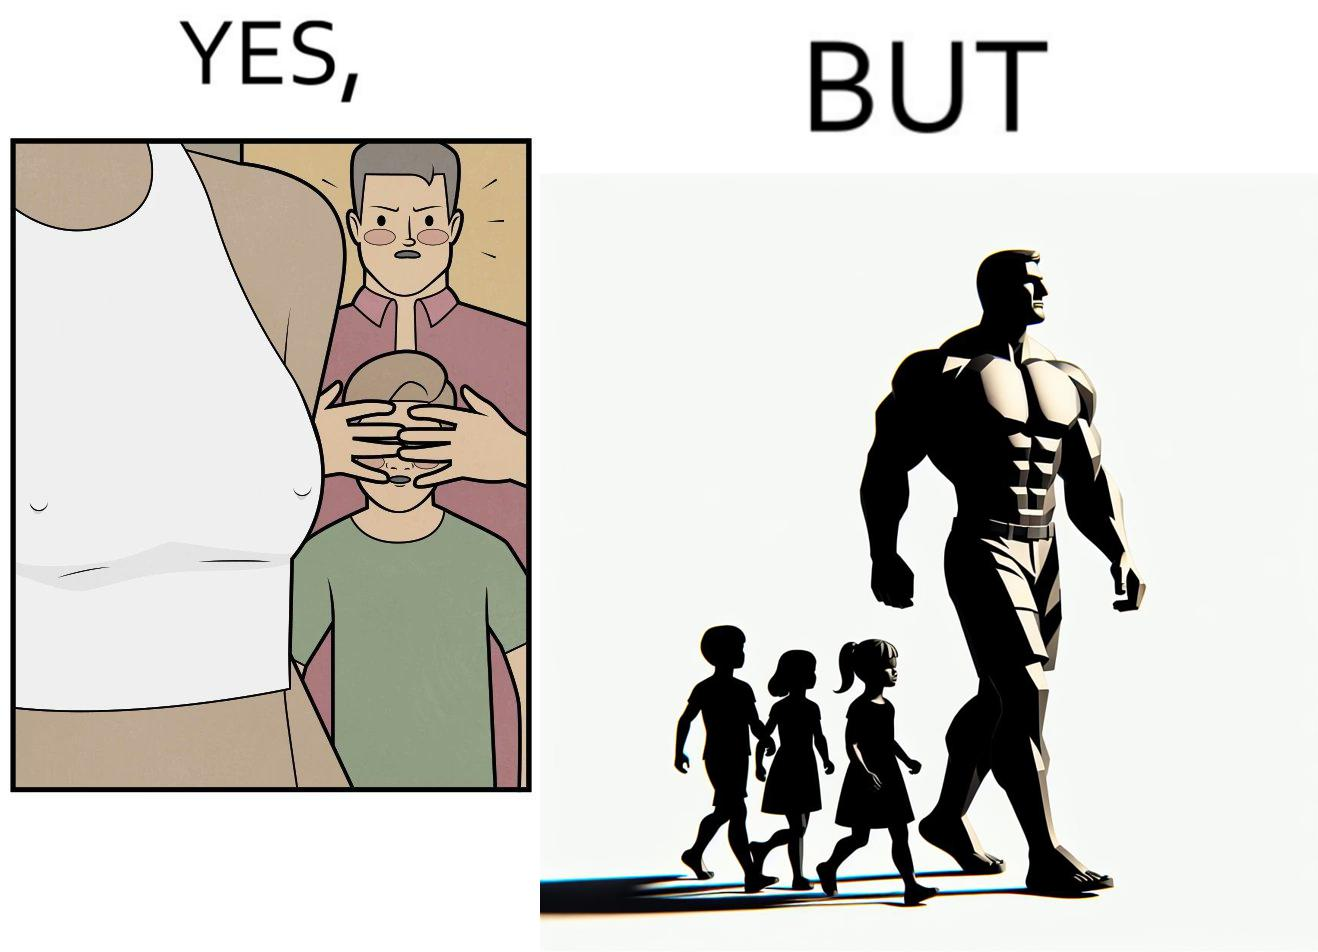Is this a satirical image? Yes, this image is satirical. 